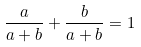<formula> <loc_0><loc_0><loc_500><loc_500>\frac { a } { a + b } + \frac { b } { a + b } = 1</formula> 